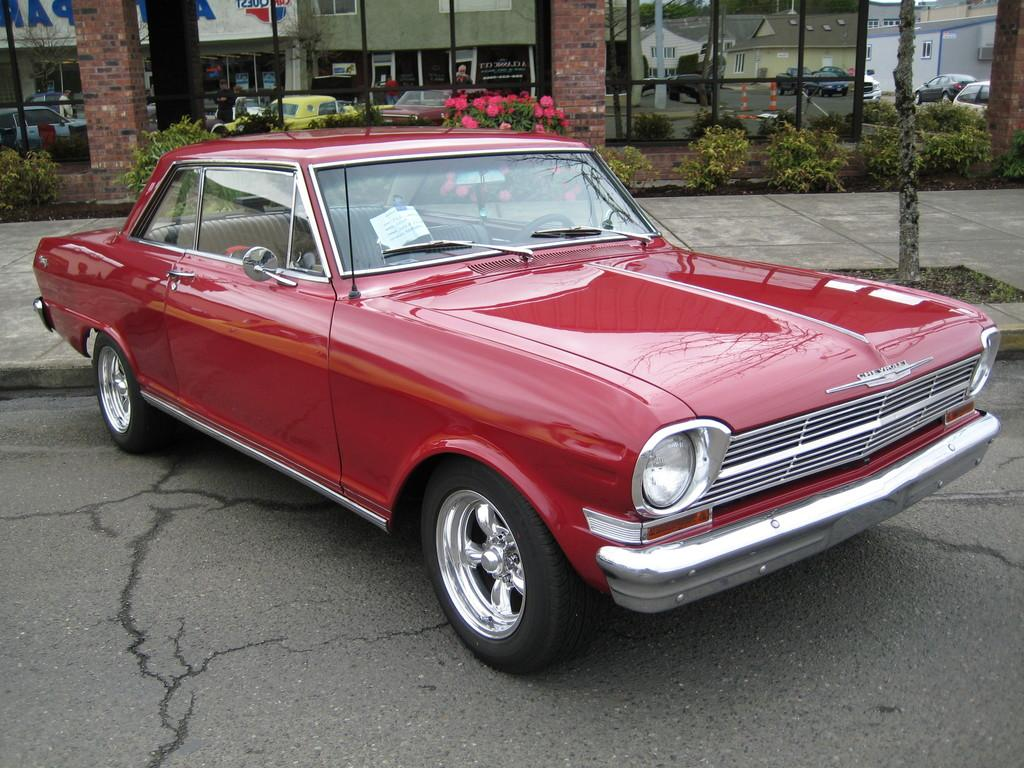What color is the car on the road in the image? The car on the road is red. What can be seen in the background of the image? In the background, there are plants, pillars, vehicles, and flowers. What is the reflection of on the glass? The reflection of buildings is visible on the glass. How many bulbs are hanging from the trees in the image? There are no bulbs hanging from the trees in the image. What type of bell can be heard ringing in the background of the image? There is no bell ringing in the background of the image. 